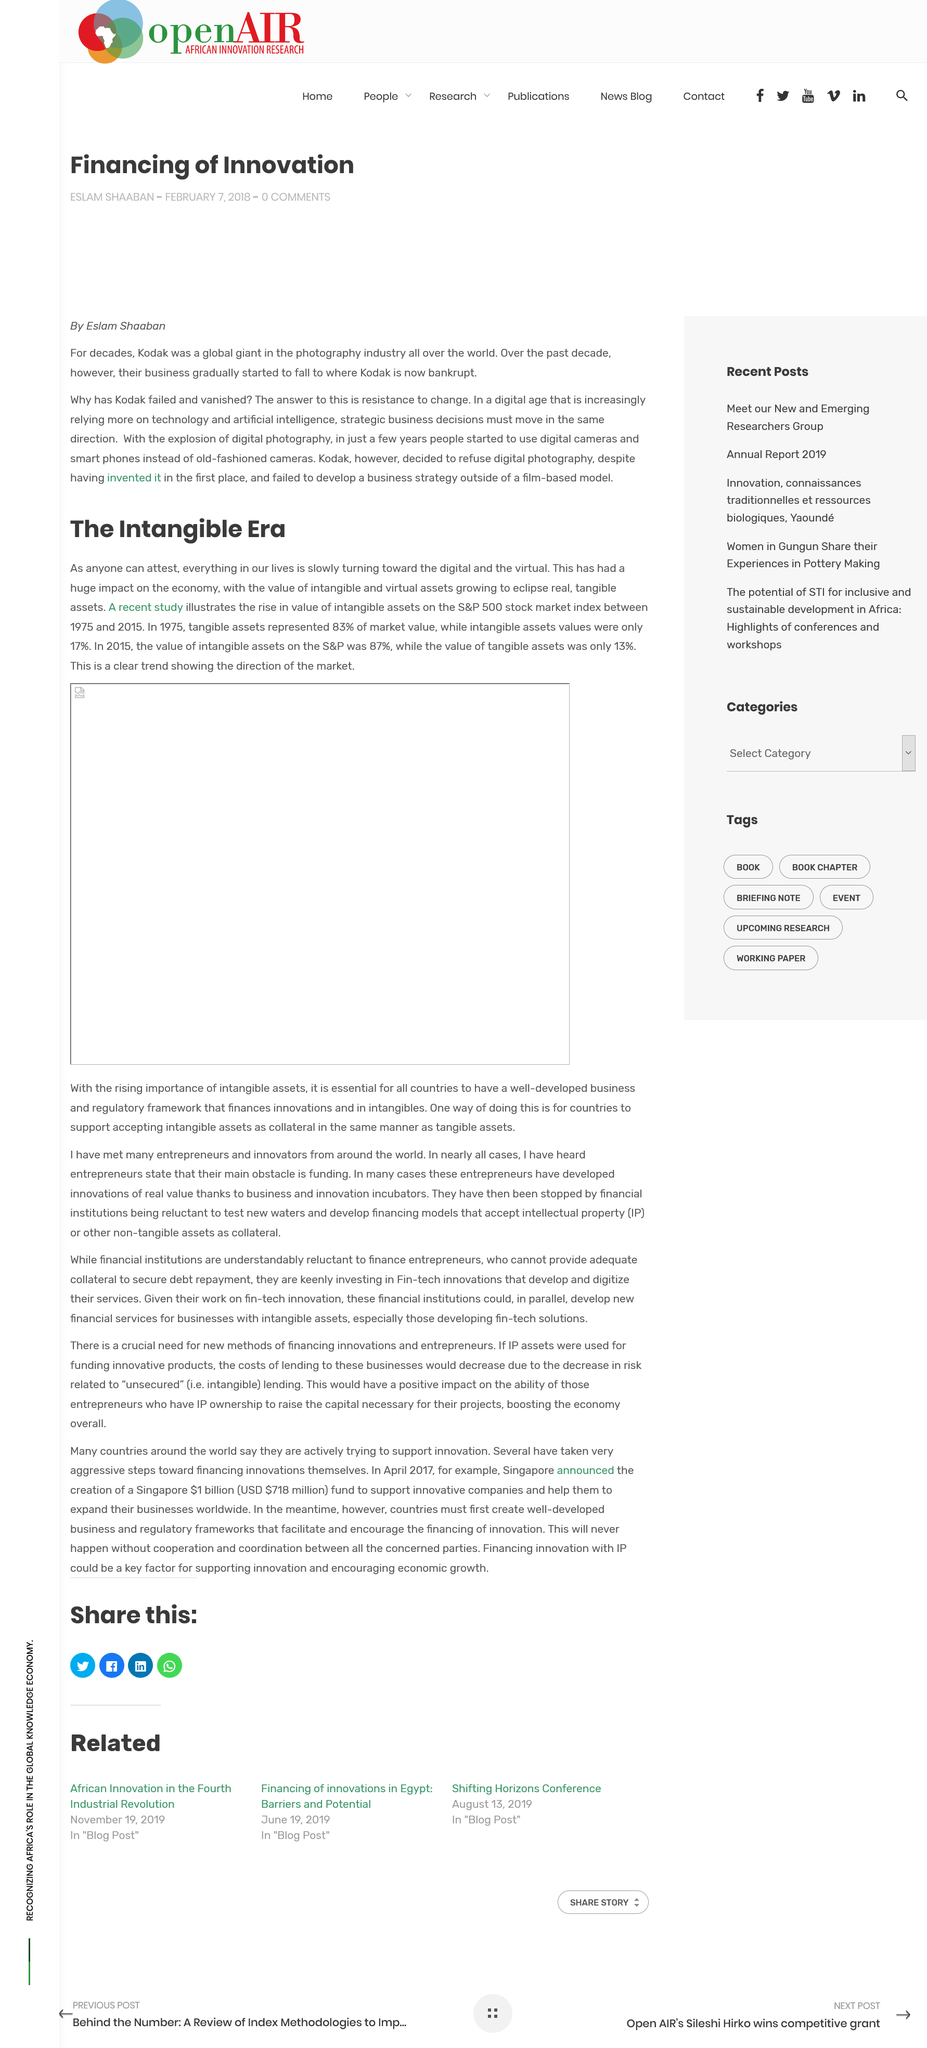Mention a couple of crucial points in this snapshot. In 1975, 83% of the assets in the S&P 500 stock market index were classified as tangible, compared to the current figure of 41%. This indicates that the proportion of tangible assets in the index has decreased over time, despite their initial dominance in market value. The recent study into tangible and intangible assets on the S&P 500 stock market index covered the time period 1975-2015. Eastman Kodak, a once-popular film manufacturer, vanished due to its resistance to change and adopting new technologies, such as digital photography. Intangible assets have surpassed tangible assets on the S&P 500 stock market index between 1975 and 2015, as demonstrated by a recent study. Kodak is not bankrupt, it is not true. 